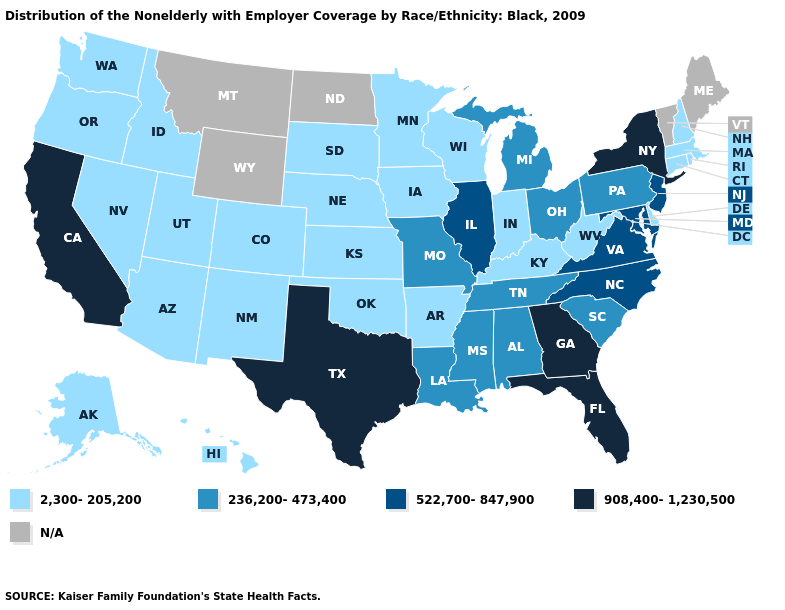What is the value of Wyoming?
Short answer required. N/A. Name the states that have a value in the range 2,300-205,200?
Short answer required. Alaska, Arizona, Arkansas, Colorado, Connecticut, Delaware, Hawaii, Idaho, Indiana, Iowa, Kansas, Kentucky, Massachusetts, Minnesota, Nebraska, Nevada, New Hampshire, New Mexico, Oklahoma, Oregon, Rhode Island, South Dakota, Utah, Washington, West Virginia, Wisconsin. Which states hav the highest value in the MidWest?
Give a very brief answer. Illinois. Which states have the lowest value in the USA?
Concise answer only. Alaska, Arizona, Arkansas, Colorado, Connecticut, Delaware, Hawaii, Idaho, Indiana, Iowa, Kansas, Kentucky, Massachusetts, Minnesota, Nebraska, Nevada, New Hampshire, New Mexico, Oklahoma, Oregon, Rhode Island, South Dakota, Utah, Washington, West Virginia, Wisconsin. What is the value of Hawaii?
Short answer required. 2,300-205,200. Does Michigan have the highest value in the USA?
Answer briefly. No. Name the states that have a value in the range 908,400-1,230,500?
Answer briefly. California, Florida, Georgia, New York, Texas. What is the highest value in the USA?
Be succinct. 908,400-1,230,500. Does Oregon have the highest value in the USA?
Write a very short answer. No. Which states have the highest value in the USA?
Answer briefly. California, Florida, Georgia, New York, Texas. What is the highest value in states that border Missouri?
Answer briefly. 522,700-847,900. Among the states that border Ohio , does Pennsylvania have the lowest value?
Keep it brief. No. Name the states that have a value in the range 908,400-1,230,500?
Answer briefly. California, Florida, Georgia, New York, Texas. 